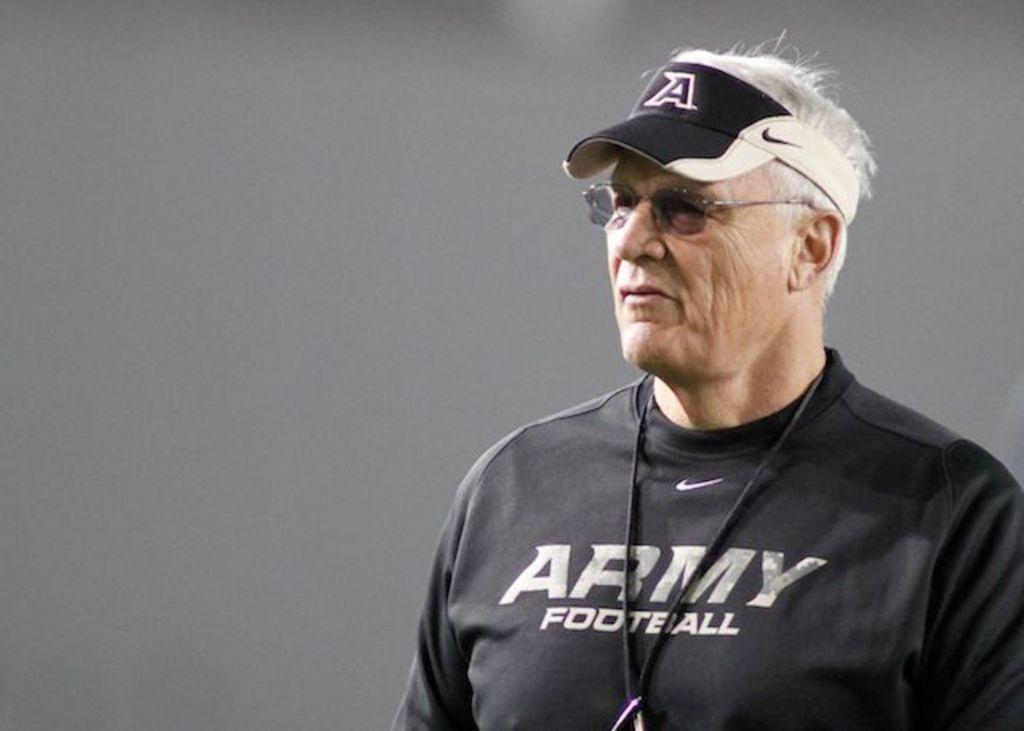Provide a one-sentence caption for the provided image. a white male wearing a nike cap and a black shirt. 